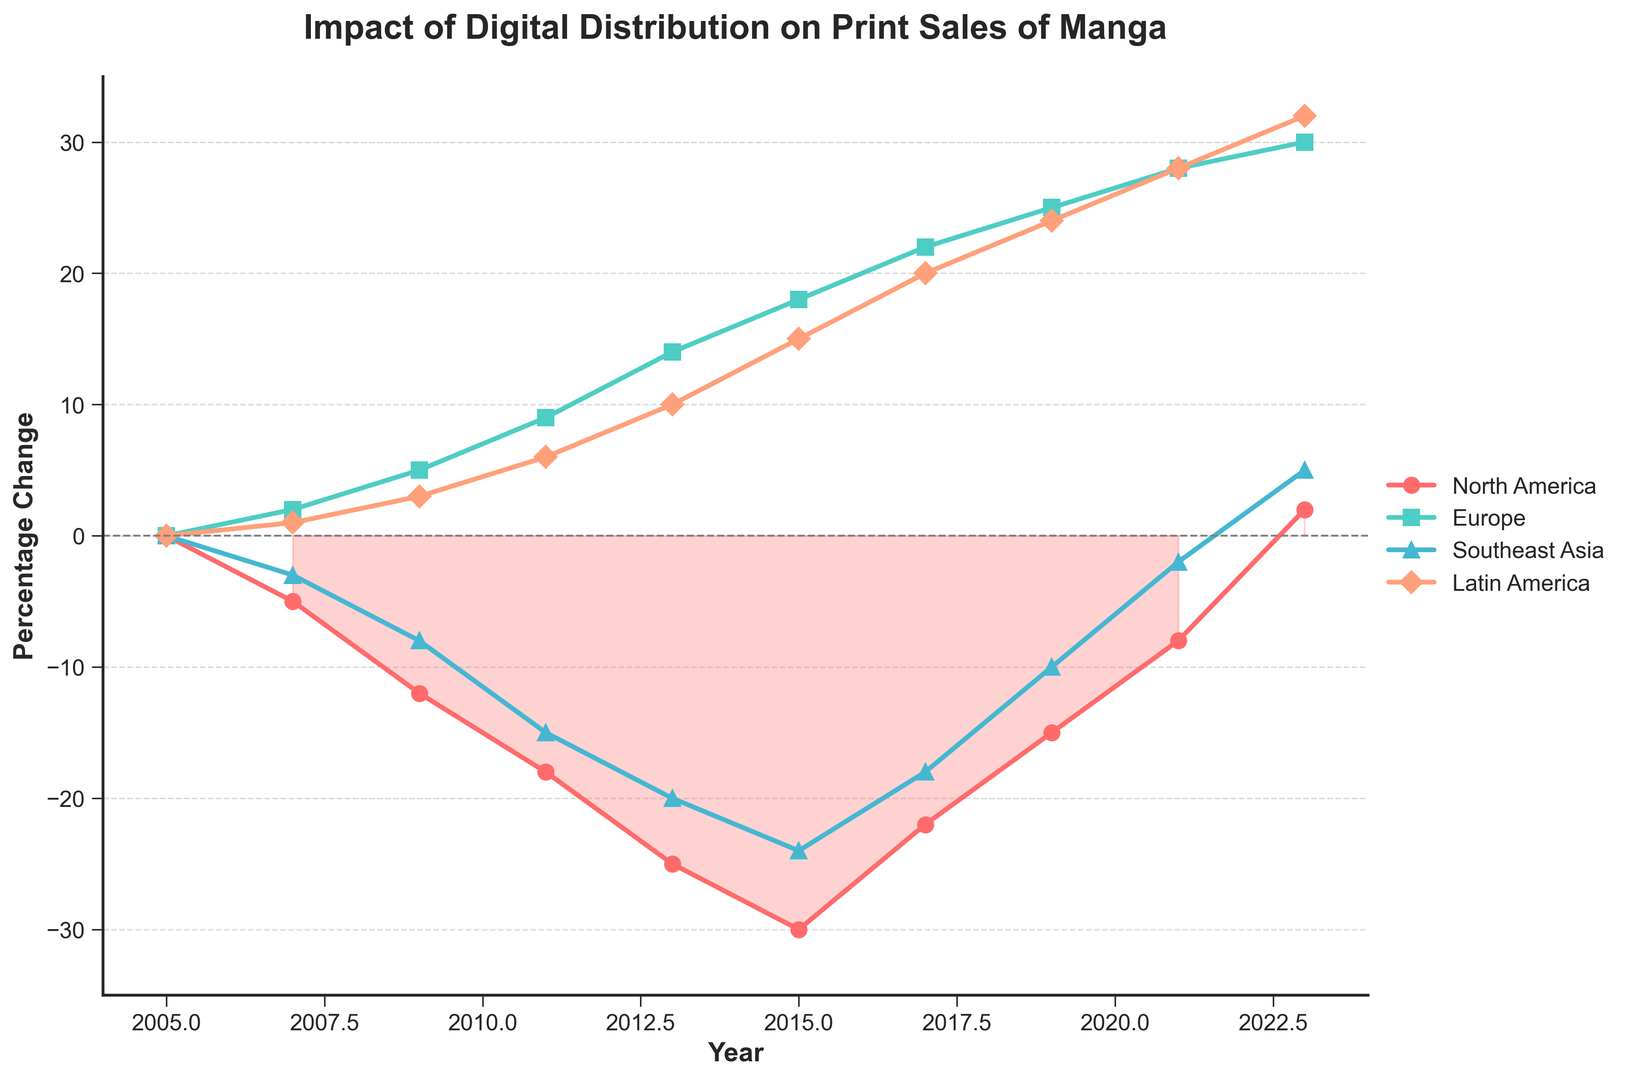What year did North America first show a positive percentage change in print sales? North America first shows a positive percentage change in print sales in 2023, as indicated by the line crossing from negative to positive values.
Answer: 2023 Which region shows a consistent upward trend in percentage change from 2005 to 2023? Looking at the chart, Europe shows a consistent upward trend, increasing its percentage change from 0% in 2005 to 30% in 2023.
Answer: Europe In which year did Latin America surpass 20% in percentage change? Observing the graph, Latin America surpasses 20% in percentage change in the year 2017.
Answer: 2017 Between which two years did Southeast Asia see the most significant improvement? Southeast Asia shows the most significant improvement between 2019 and 2023, as the line rises sharply from -2% to 5%.
Answer: 2019 and 2023 What is the difference in percentage change between North America and Europe in 2011? In 2011, North America is at -18% and Europe is at 9%. The difference is calculated as 9 - (-18), which equals 27%.
Answer: 27% Which region had the steepest decline between 2005 and 2013? Observing the chart, North America experiences the steepest decline from 0% in 2005 to -25% in 2013.
Answer: North America What is the average percentage change for Latin America over the span of years provided? Summing up all given changes for Latin America: 0 + 1 + 3 + 6 + 10 + 15 + 20 + 24 + 28 + 32 = 139. There are 10 data points, so the average is 139 / 10 = 13.9%.
Answer: 13.9% How did the percentage change in print sales for North America between 2015 to 2017 compare with Europe in the same period? Between 2015 and 2017, North America’s percentage change improved from -30% to -22%, an increase of 8%. Europe’s percentage change improved from 18% to 22%, an increase of 4%.
Answer: North America improved more Did any region show a negative percentage change in 2023? In 2023, all regions show positive percentage changes; North America is at 2%, Europe at 30%, Southeast Asia at 5%, and Latin America at 32%.
Answer: No Which region had the largest positive change in print sales percentage from 2005 to 2023? Observing the graph, Europe had the largest positive change, moving from 0% in 2005 to 30% in 2023, an overall increase of 30%.
Answer: Europe 